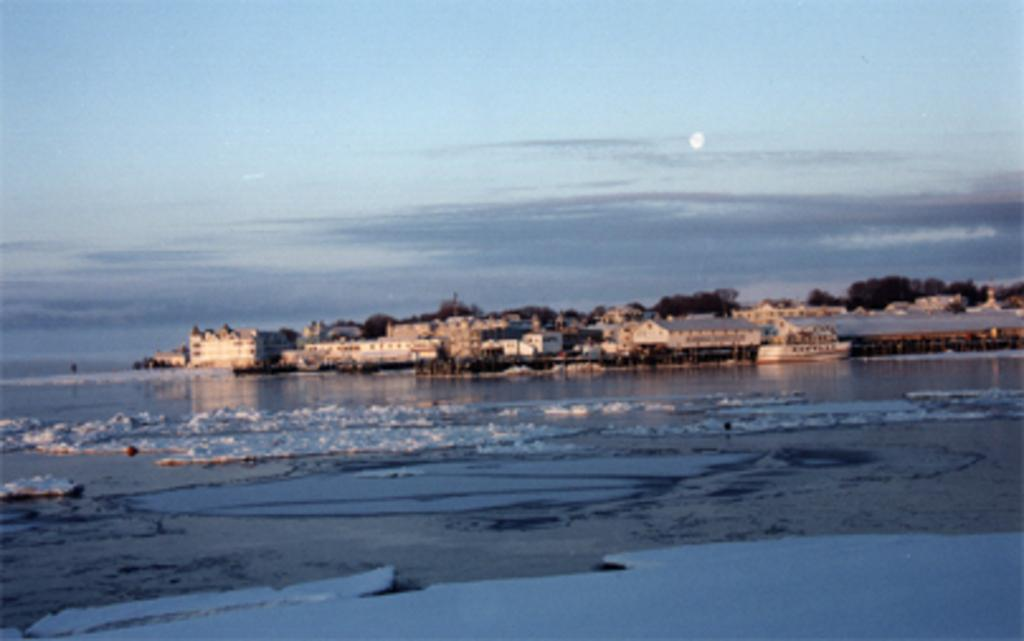What is the primary element visible in the image? There is water in the image. What can be seen behind the water? There are buildings behind the water. What is the condition of the sky in the image? The sky is clear and visible at the top of the image. Where is the garden located in the image? There is no garden present in the image. How many boys can be seen playing in the water in the image? There are no boys present in the image. 